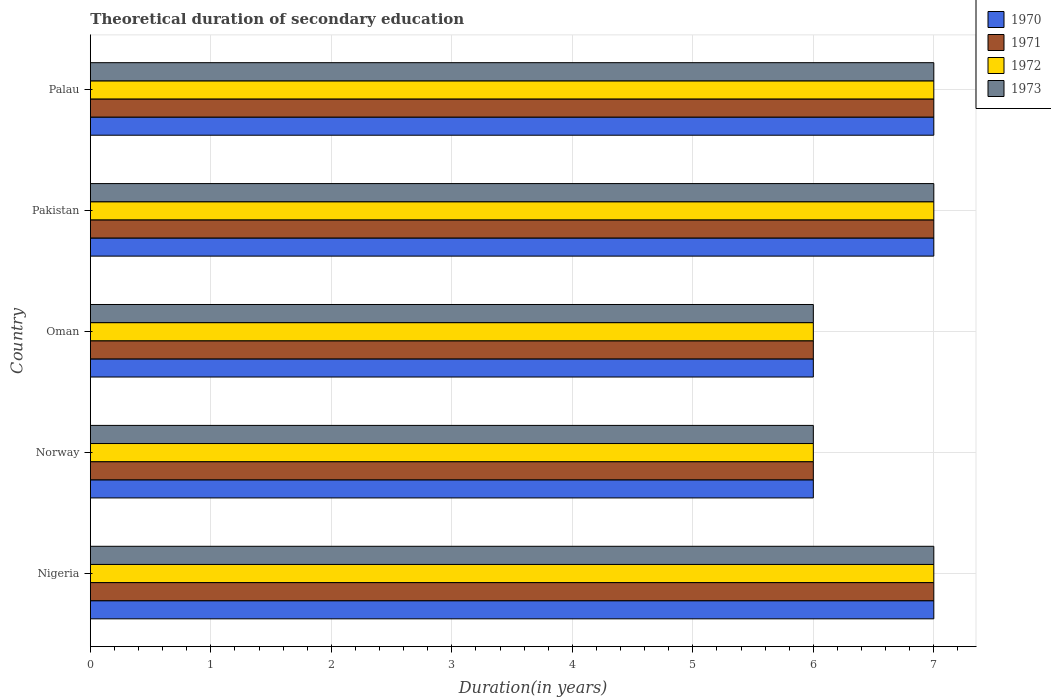How many different coloured bars are there?
Your answer should be very brief. 4. How many groups of bars are there?
Give a very brief answer. 5. Are the number of bars per tick equal to the number of legend labels?
Ensure brevity in your answer.  Yes. In how many cases, is the number of bars for a given country not equal to the number of legend labels?
Your answer should be very brief. 0. Across all countries, what is the maximum total theoretical duration of secondary education in 1971?
Keep it short and to the point. 7. Across all countries, what is the minimum total theoretical duration of secondary education in 1973?
Ensure brevity in your answer.  6. In which country was the total theoretical duration of secondary education in 1970 maximum?
Give a very brief answer. Nigeria. What is the total total theoretical duration of secondary education in 1973 in the graph?
Your answer should be compact. 33. What is the difference between the total theoretical duration of secondary education in 1973 in Oman and that in Palau?
Make the answer very short. -1. What is the difference between the total theoretical duration of secondary education in 1972 and total theoretical duration of secondary education in 1971 in Oman?
Give a very brief answer. 0. What is the ratio of the total theoretical duration of secondary education in 1973 in Norway to that in Oman?
Keep it short and to the point. 1. What is the difference between the highest and the second highest total theoretical duration of secondary education in 1972?
Provide a succinct answer. 0. In how many countries, is the total theoretical duration of secondary education in 1970 greater than the average total theoretical duration of secondary education in 1970 taken over all countries?
Your answer should be compact. 3. Is the sum of the total theoretical duration of secondary education in 1971 in Norway and Palau greater than the maximum total theoretical duration of secondary education in 1973 across all countries?
Your answer should be compact. Yes. Is it the case that in every country, the sum of the total theoretical duration of secondary education in 1972 and total theoretical duration of secondary education in 1971 is greater than the sum of total theoretical duration of secondary education in 1973 and total theoretical duration of secondary education in 1970?
Offer a terse response. No. What does the 2nd bar from the top in Nigeria represents?
Provide a short and direct response. 1972. What does the 2nd bar from the bottom in Norway represents?
Offer a terse response. 1971. Are all the bars in the graph horizontal?
Offer a terse response. Yes. How many countries are there in the graph?
Your answer should be compact. 5. What is the difference between two consecutive major ticks on the X-axis?
Give a very brief answer. 1. Where does the legend appear in the graph?
Your answer should be compact. Top right. How are the legend labels stacked?
Provide a short and direct response. Vertical. What is the title of the graph?
Your response must be concise. Theoretical duration of secondary education. Does "1988" appear as one of the legend labels in the graph?
Your response must be concise. No. What is the label or title of the X-axis?
Provide a succinct answer. Duration(in years). What is the label or title of the Y-axis?
Ensure brevity in your answer.  Country. What is the Duration(in years) of 1972 in Nigeria?
Offer a terse response. 7. What is the Duration(in years) in 1973 in Nigeria?
Offer a terse response. 7. What is the Duration(in years) in 1970 in Norway?
Make the answer very short. 6. What is the Duration(in years) of 1971 in Norway?
Offer a terse response. 6. What is the Duration(in years) in 1973 in Norway?
Ensure brevity in your answer.  6. What is the Duration(in years) of 1970 in Oman?
Ensure brevity in your answer.  6. What is the Duration(in years) of 1971 in Pakistan?
Provide a succinct answer. 7. What is the Duration(in years) in 1973 in Pakistan?
Your answer should be compact. 7. What is the Duration(in years) in 1972 in Palau?
Offer a terse response. 7. Across all countries, what is the maximum Duration(in years) of 1972?
Give a very brief answer. 7. Across all countries, what is the minimum Duration(in years) in 1970?
Offer a very short reply. 6. Across all countries, what is the minimum Duration(in years) in 1972?
Your response must be concise. 6. What is the total Duration(in years) in 1971 in the graph?
Your answer should be very brief. 33. What is the difference between the Duration(in years) in 1970 in Nigeria and that in Norway?
Offer a very short reply. 1. What is the difference between the Duration(in years) of 1972 in Nigeria and that in Norway?
Your answer should be compact. 1. What is the difference between the Duration(in years) of 1973 in Nigeria and that in Norway?
Your response must be concise. 1. What is the difference between the Duration(in years) of 1970 in Nigeria and that in Oman?
Ensure brevity in your answer.  1. What is the difference between the Duration(in years) in 1971 in Nigeria and that in Oman?
Your response must be concise. 1. What is the difference between the Duration(in years) in 1970 in Nigeria and that in Pakistan?
Provide a succinct answer. 0. What is the difference between the Duration(in years) in 1973 in Nigeria and that in Pakistan?
Offer a very short reply. 0. What is the difference between the Duration(in years) in 1972 in Nigeria and that in Palau?
Provide a short and direct response. 0. What is the difference between the Duration(in years) in 1973 in Nigeria and that in Palau?
Provide a succinct answer. 0. What is the difference between the Duration(in years) in 1970 in Norway and that in Oman?
Your answer should be very brief. 0. What is the difference between the Duration(in years) in 1970 in Norway and that in Pakistan?
Provide a short and direct response. -1. What is the difference between the Duration(in years) of 1972 in Norway and that in Pakistan?
Keep it short and to the point. -1. What is the difference between the Duration(in years) of 1970 in Norway and that in Palau?
Provide a short and direct response. -1. What is the difference between the Duration(in years) of 1973 in Norway and that in Palau?
Your answer should be compact. -1. What is the difference between the Duration(in years) of 1970 in Oman and that in Pakistan?
Make the answer very short. -1. What is the difference between the Duration(in years) of 1971 in Oman and that in Pakistan?
Keep it short and to the point. -1. What is the difference between the Duration(in years) of 1972 in Oman and that in Pakistan?
Your answer should be very brief. -1. What is the difference between the Duration(in years) of 1973 in Oman and that in Pakistan?
Provide a succinct answer. -1. What is the difference between the Duration(in years) of 1970 in Oman and that in Palau?
Provide a short and direct response. -1. What is the difference between the Duration(in years) in 1973 in Oman and that in Palau?
Your answer should be compact. -1. What is the difference between the Duration(in years) in 1972 in Pakistan and that in Palau?
Ensure brevity in your answer.  0. What is the difference between the Duration(in years) of 1973 in Pakistan and that in Palau?
Your answer should be very brief. 0. What is the difference between the Duration(in years) in 1970 in Nigeria and the Duration(in years) in 1972 in Norway?
Give a very brief answer. 1. What is the difference between the Duration(in years) of 1971 in Nigeria and the Duration(in years) of 1973 in Norway?
Provide a succinct answer. 1. What is the difference between the Duration(in years) in 1970 in Nigeria and the Duration(in years) in 1972 in Oman?
Your answer should be compact. 1. What is the difference between the Duration(in years) of 1971 in Nigeria and the Duration(in years) of 1972 in Oman?
Give a very brief answer. 1. What is the difference between the Duration(in years) in 1972 in Nigeria and the Duration(in years) in 1973 in Oman?
Provide a short and direct response. 1. What is the difference between the Duration(in years) in 1970 in Nigeria and the Duration(in years) in 1971 in Pakistan?
Your answer should be compact. 0. What is the difference between the Duration(in years) of 1970 in Nigeria and the Duration(in years) of 1973 in Pakistan?
Give a very brief answer. 0. What is the difference between the Duration(in years) of 1971 in Nigeria and the Duration(in years) of 1973 in Pakistan?
Your response must be concise. 0. What is the difference between the Duration(in years) in 1970 in Nigeria and the Duration(in years) in 1973 in Palau?
Offer a terse response. 0. What is the difference between the Duration(in years) in 1971 in Nigeria and the Duration(in years) in 1972 in Palau?
Keep it short and to the point. 0. What is the difference between the Duration(in years) in 1971 in Nigeria and the Duration(in years) in 1973 in Palau?
Provide a succinct answer. 0. What is the difference between the Duration(in years) in 1970 in Norway and the Duration(in years) in 1972 in Oman?
Your answer should be very brief. 0. What is the difference between the Duration(in years) in 1971 in Norway and the Duration(in years) in 1973 in Oman?
Provide a succinct answer. 0. What is the difference between the Duration(in years) of 1970 in Norway and the Duration(in years) of 1971 in Pakistan?
Offer a very short reply. -1. What is the difference between the Duration(in years) of 1970 in Norway and the Duration(in years) of 1972 in Pakistan?
Provide a short and direct response. -1. What is the difference between the Duration(in years) in 1971 in Norway and the Duration(in years) in 1973 in Pakistan?
Give a very brief answer. -1. What is the difference between the Duration(in years) in 1972 in Norway and the Duration(in years) in 1973 in Pakistan?
Provide a short and direct response. -1. What is the difference between the Duration(in years) in 1970 in Norway and the Duration(in years) in 1971 in Palau?
Provide a succinct answer. -1. What is the difference between the Duration(in years) in 1971 in Norway and the Duration(in years) in 1972 in Palau?
Give a very brief answer. -1. What is the difference between the Duration(in years) in 1971 in Norway and the Duration(in years) in 1973 in Palau?
Your answer should be very brief. -1. What is the difference between the Duration(in years) in 1970 in Oman and the Duration(in years) in 1972 in Pakistan?
Your answer should be very brief. -1. What is the difference between the Duration(in years) in 1970 in Oman and the Duration(in years) in 1972 in Palau?
Provide a short and direct response. -1. What is the difference between the Duration(in years) in 1970 in Oman and the Duration(in years) in 1973 in Palau?
Ensure brevity in your answer.  -1. What is the difference between the Duration(in years) of 1971 in Oman and the Duration(in years) of 1972 in Palau?
Provide a short and direct response. -1. What is the difference between the Duration(in years) of 1972 in Oman and the Duration(in years) of 1973 in Palau?
Provide a short and direct response. -1. What is the difference between the Duration(in years) in 1971 in Pakistan and the Duration(in years) in 1972 in Palau?
Provide a short and direct response. 0. What is the difference between the Duration(in years) in 1971 in Pakistan and the Duration(in years) in 1973 in Palau?
Ensure brevity in your answer.  0. What is the difference between the Duration(in years) in 1972 in Pakistan and the Duration(in years) in 1973 in Palau?
Give a very brief answer. 0. What is the average Duration(in years) in 1970 per country?
Provide a short and direct response. 6.6. What is the average Duration(in years) of 1971 per country?
Offer a very short reply. 6.6. What is the average Duration(in years) in 1973 per country?
Your answer should be compact. 6.6. What is the difference between the Duration(in years) of 1970 and Duration(in years) of 1972 in Nigeria?
Provide a succinct answer. 0. What is the difference between the Duration(in years) of 1971 and Duration(in years) of 1972 in Nigeria?
Provide a short and direct response. 0. What is the difference between the Duration(in years) of 1970 and Duration(in years) of 1973 in Norway?
Keep it short and to the point. 0. What is the difference between the Duration(in years) of 1972 and Duration(in years) of 1973 in Norway?
Give a very brief answer. 0. What is the difference between the Duration(in years) in 1970 and Duration(in years) in 1973 in Oman?
Ensure brevity in your answer.  0. What is the difference between the Duration(in years) of 1971 and Duration(in years) of 1973 in Pakistan?
Provide a short and direct response. 0. What is the difference between the Duration(in years) of 1972 and Duration(in years) of 1973 in Pakistan?
Make the answer very short. 0. What is the difference between the Duration(in years) in 1970 and Duration(in years) in 1972 in Palau?
Your response must be concise. 0. What is the difference between the Duration(in years) in 1970 and Duration(in years) in 1973 in Palau?
Your response must be concise. 0. What is the difference between the Duration(in years) in 1971 and Duration(in years) in 1972 in Palau?
Your answer should be very brief. 0. What is the ratio of the Duration(in years) of 1970 in Nigeria to that in Norway?
Give a very brief answer. 1.17. What is the ratio of the Duration(in years) in 1971 in Nigeria to that in Norway?
Your response must be concise. 1.17. What is the ratio of the Duration(in years) in 1970 in Nigeria to that in Oman?
Offer a very short reply. 1.17. What is the ratio of the Duration(in years) of 1971 in Nigeria to that in Oman?
Make the answer very short. 1.17. What is the ratio of the Duration(in years) of 1973 in Nigeria to that in Oman?
Make the answer very short. 1.17. What is the ratio of the Duration(in years) in 1970 in Nigeria to that in Pakistan?
Offer a very short reply. 1. What is the ratio of the Duration(in years) in 1971 in Nigeria to that in Pakistan?
Keep it short and to the point. 1. What is the ratio of the Duration(in years) of 1973 in Nigeria to that in Pakistan?
Ensure brevity in your answer.  1. What is the ratio of the Duration(in years) of 1973 in Nigeria to that in Palau?
Keep it short and to the point. 1. What is the ratio of the Duration(in years) of 1970 in Norway to that in Oman?
Offer a very short reply. 1. What is the ratio of the Duration(in years) of 1971 in Norway to that in Oman?
Ensure brevity in your answer.  1. What is the ratio of the Duration(in years) of 1973 in Norway to that in Oman?
Provide a short and direct response. 1. What is the ratio of the Duration(in years) in 1970 in Norway to that in Pakistan?
Offer a terse response. 0.86. What is the ratio of the Duration(in years) in 1972 in Norway to that in Pakistan?
Ensure brevity in your answer.  0.86. What is the ratio of the Duration(in years) in 1973 in Norway to that in Pakistan?
Keep it short and to the point. 0.86. What is the ratio of the Duration(in years) of 1970 in Norway to that in Palau?
Provide a succinct answer. 0.86. What is the ratio of the Duration(in years) in 1971 in Norway to that in Palau?
Your answer should be very brief. 0.86. What is the ratio of the Duration(in years) in 1972 in Norway to that in Palau?
Your response must be concise. 0.86. What is the ratio of the Duration(in years) of 1971 in Oman to that in Pakistan?
Keep it short and to the point. 0.86. What is the ratio of the Duration(in years) of 1970 in Oman to that in Palau?
Provide a succinct answer. 0.86. What is the ratio of the Duration(in years) of 1973 in Oman to that in Palau?
Your answer should be compact. 0.86. What is the ratio of the Duration(in years) in 1971 in Pakistan to that in Palau?
Provide a short and direct response. 1. What is the ratio of the Duration(in years) of 1972 in Pakistan to that in Palau?
Your answer should be very brief. 1. What is the difference between the highest and the second highest Duration(in years) of 1970?
Provide a succinct answer. 0. What is the difference between the highest and the second highest Duration(in years) in 1972?
Ensure brevity in your answer.  0. What is the difference between the highest and the lowest Duration(in years) in 1970?
Provide a short and direct response. 1. What is the difference between the highest and the lowest Duration(in years) in 1971?
Keep it short and to the point. 1. What is the difference between the highest and the lowest Duration(in years) in 1972?
Your response must be concise. 1. What is the difference between the highest and the lowest Duration(in years) of 1973?
Your answer should be compact. 1. 